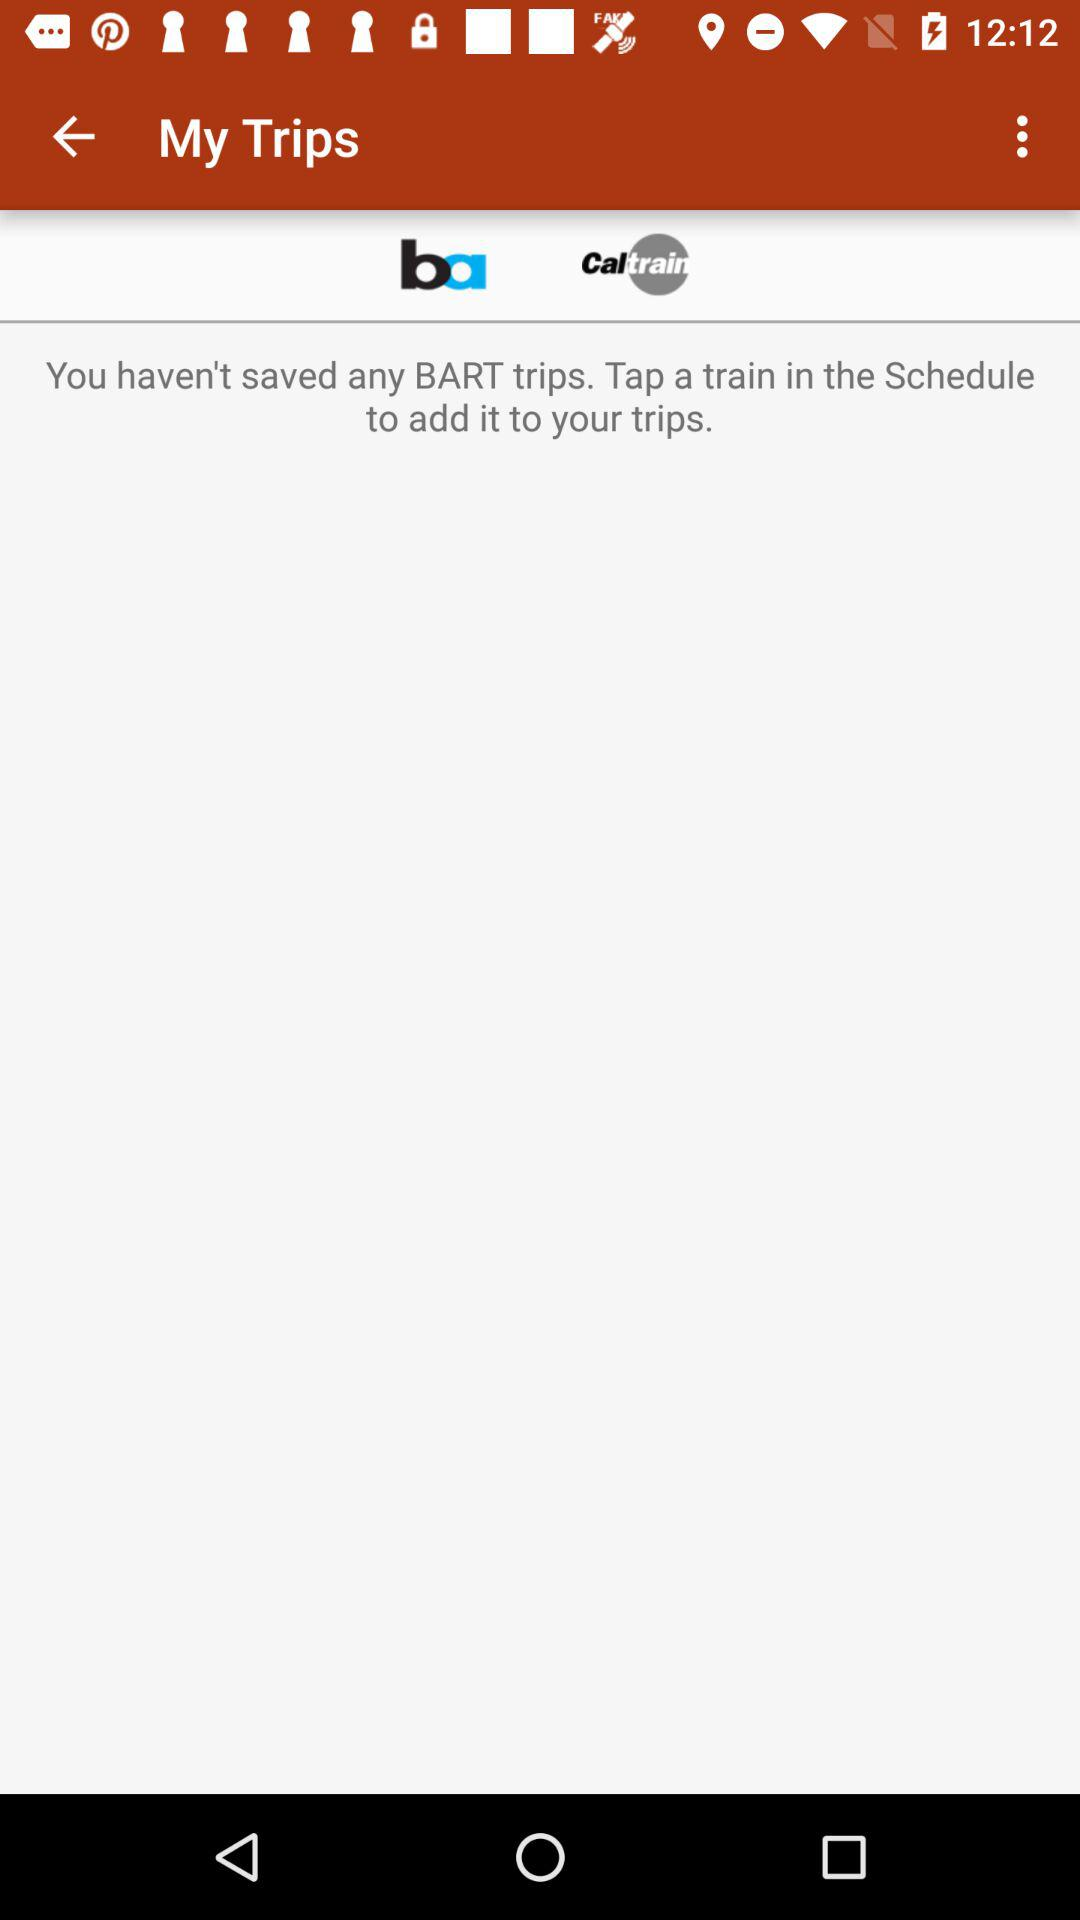How many transit systems are available for selection?
Answer the question using a single word or phrase. 2 